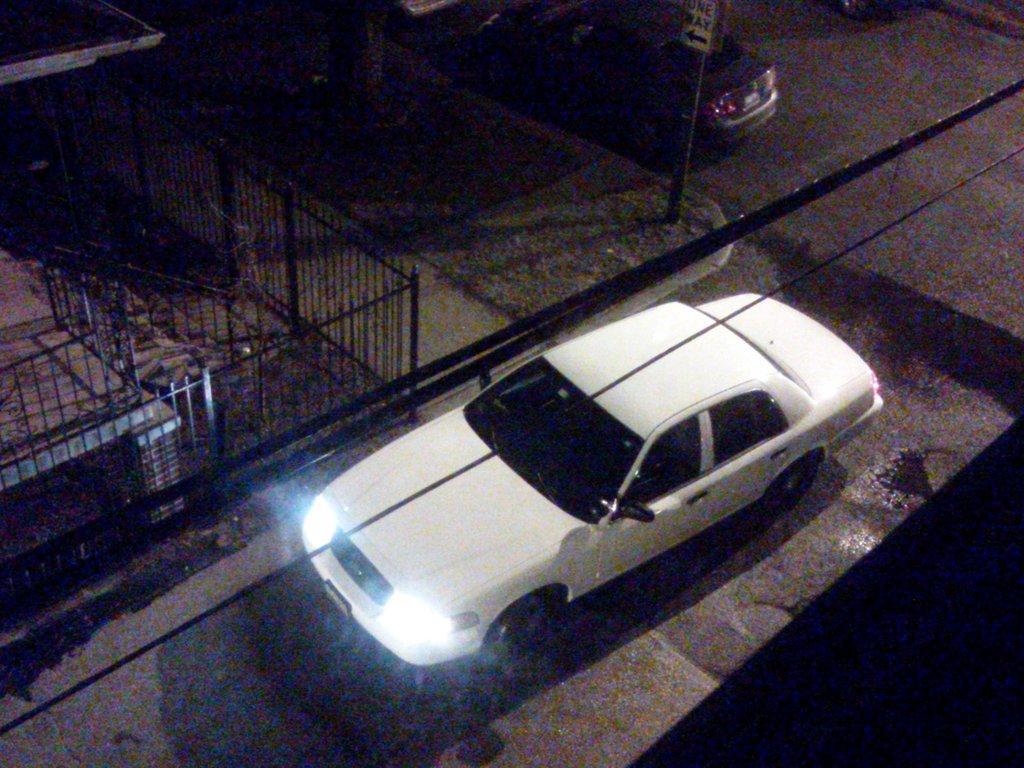Describe this image in one or two sentences. In this image we can able to see two cars, and there is a fencing, and there is a sign board. 